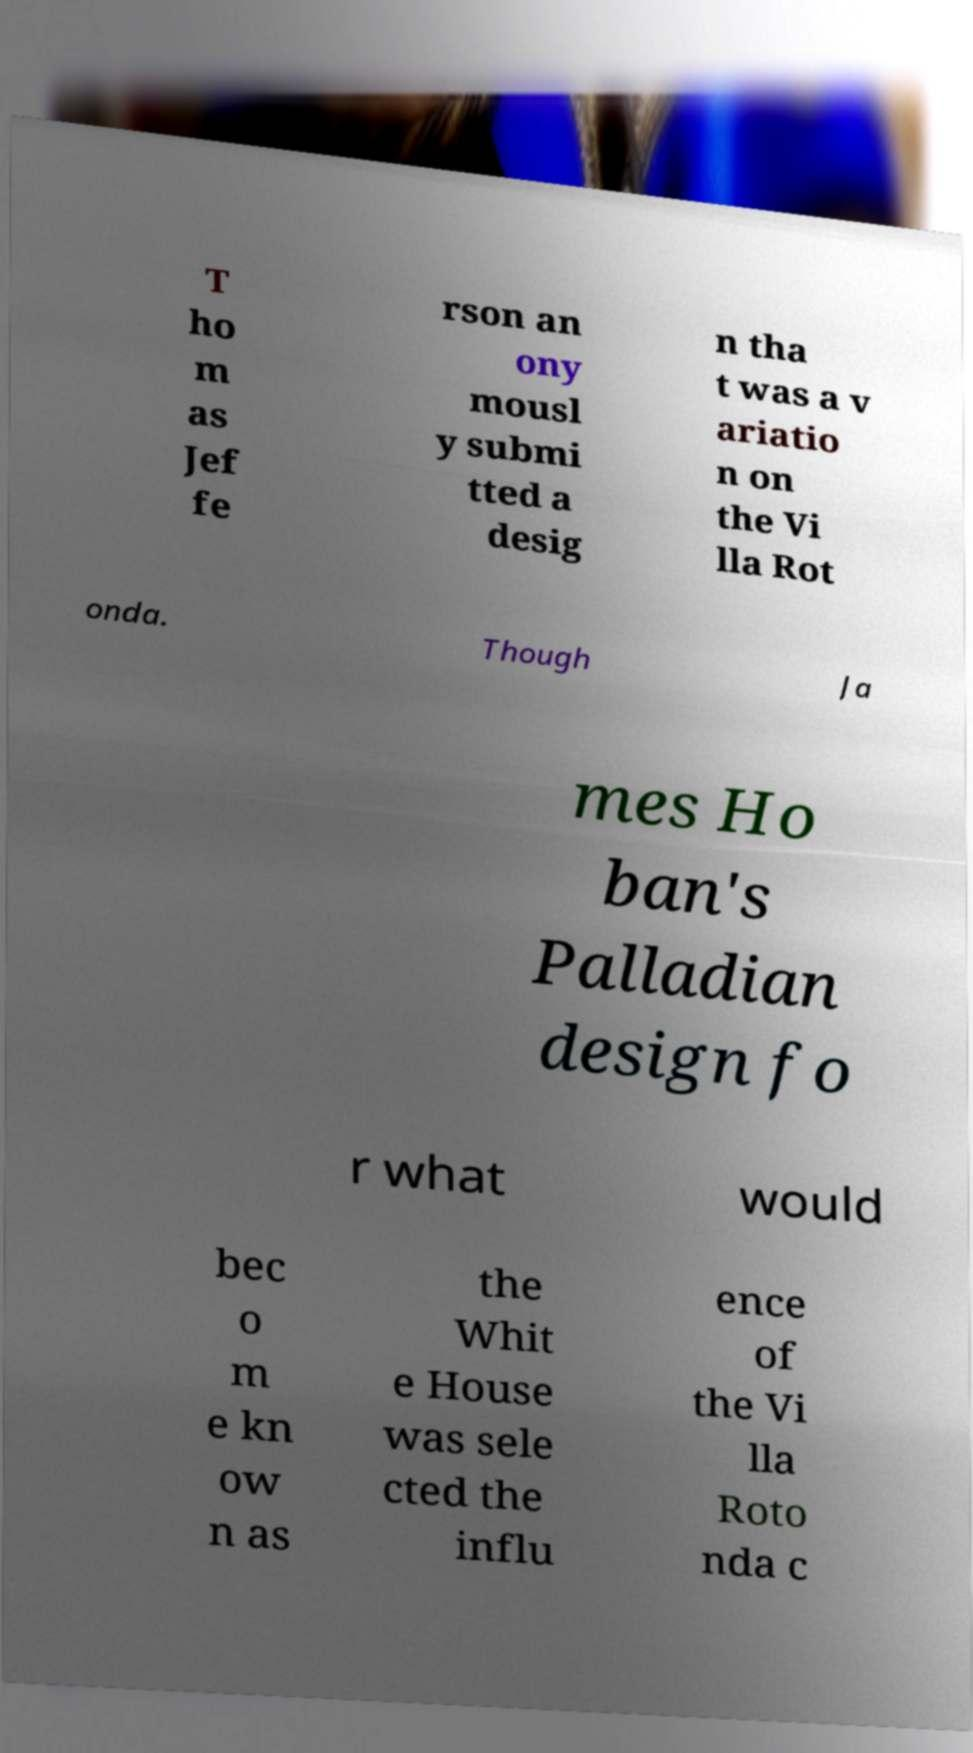Can you accurately transcribe the text from the provided image for me? T ho m as Jef fe rson an ony mousl y submi tted a desig n tha t was a v ariatio n on the Vi lla Rot onda. Though Ja mes Ho ban's Palladian design fo r what would bec o m e kn ow n as the Whit e House was sele cted the influ ence of the Vi lla Roto nda c 